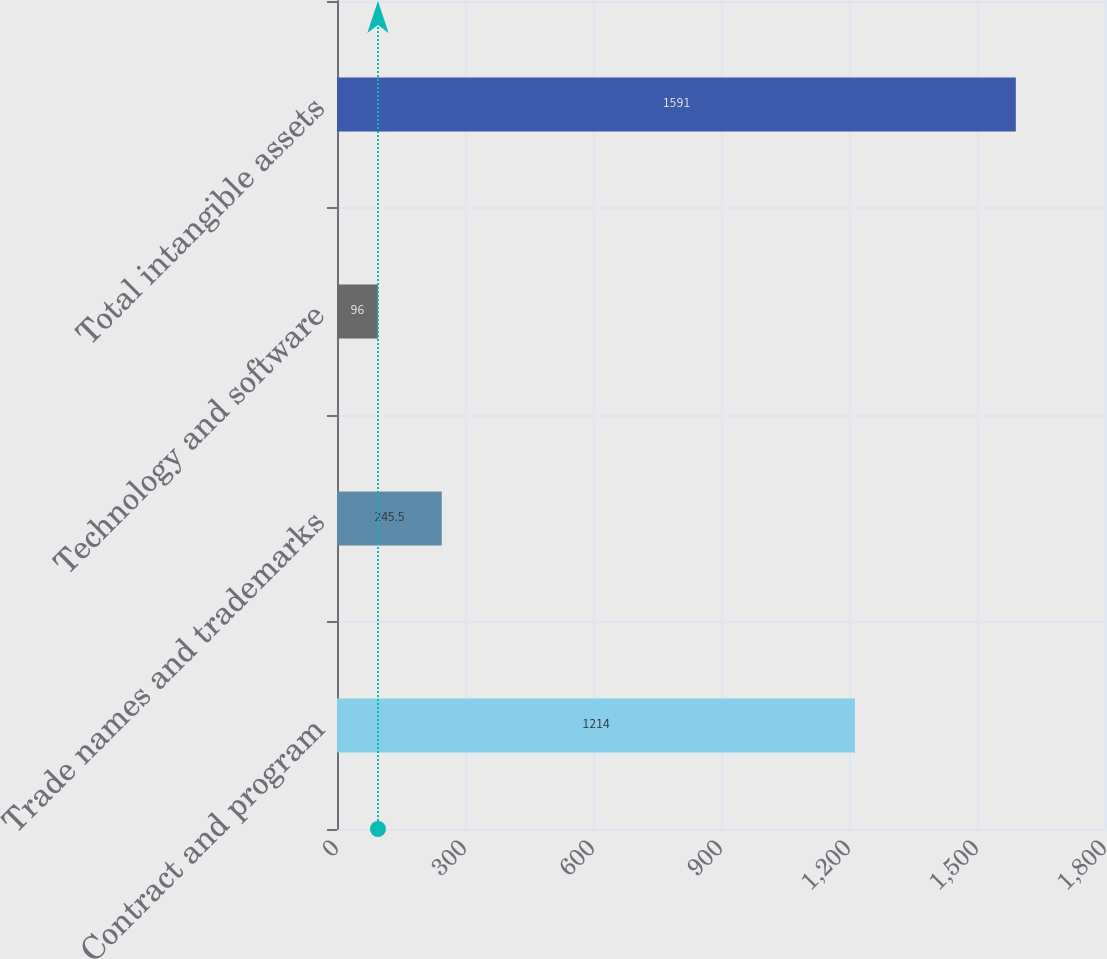Convert chart to OTSL. <chart><loc_0><loc_0><loc_500><loc_500><bar_chart><fcel>Contract and program<fcel>Trade names and trademarks<fcel>Technology and software<fcel>Total intangible assets<nl><fcel>1214<fcel>245.5<fcel>96<fcel>1591<nl></chart> 